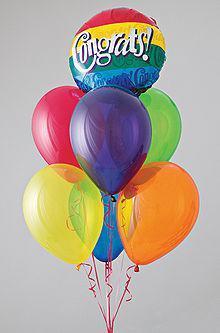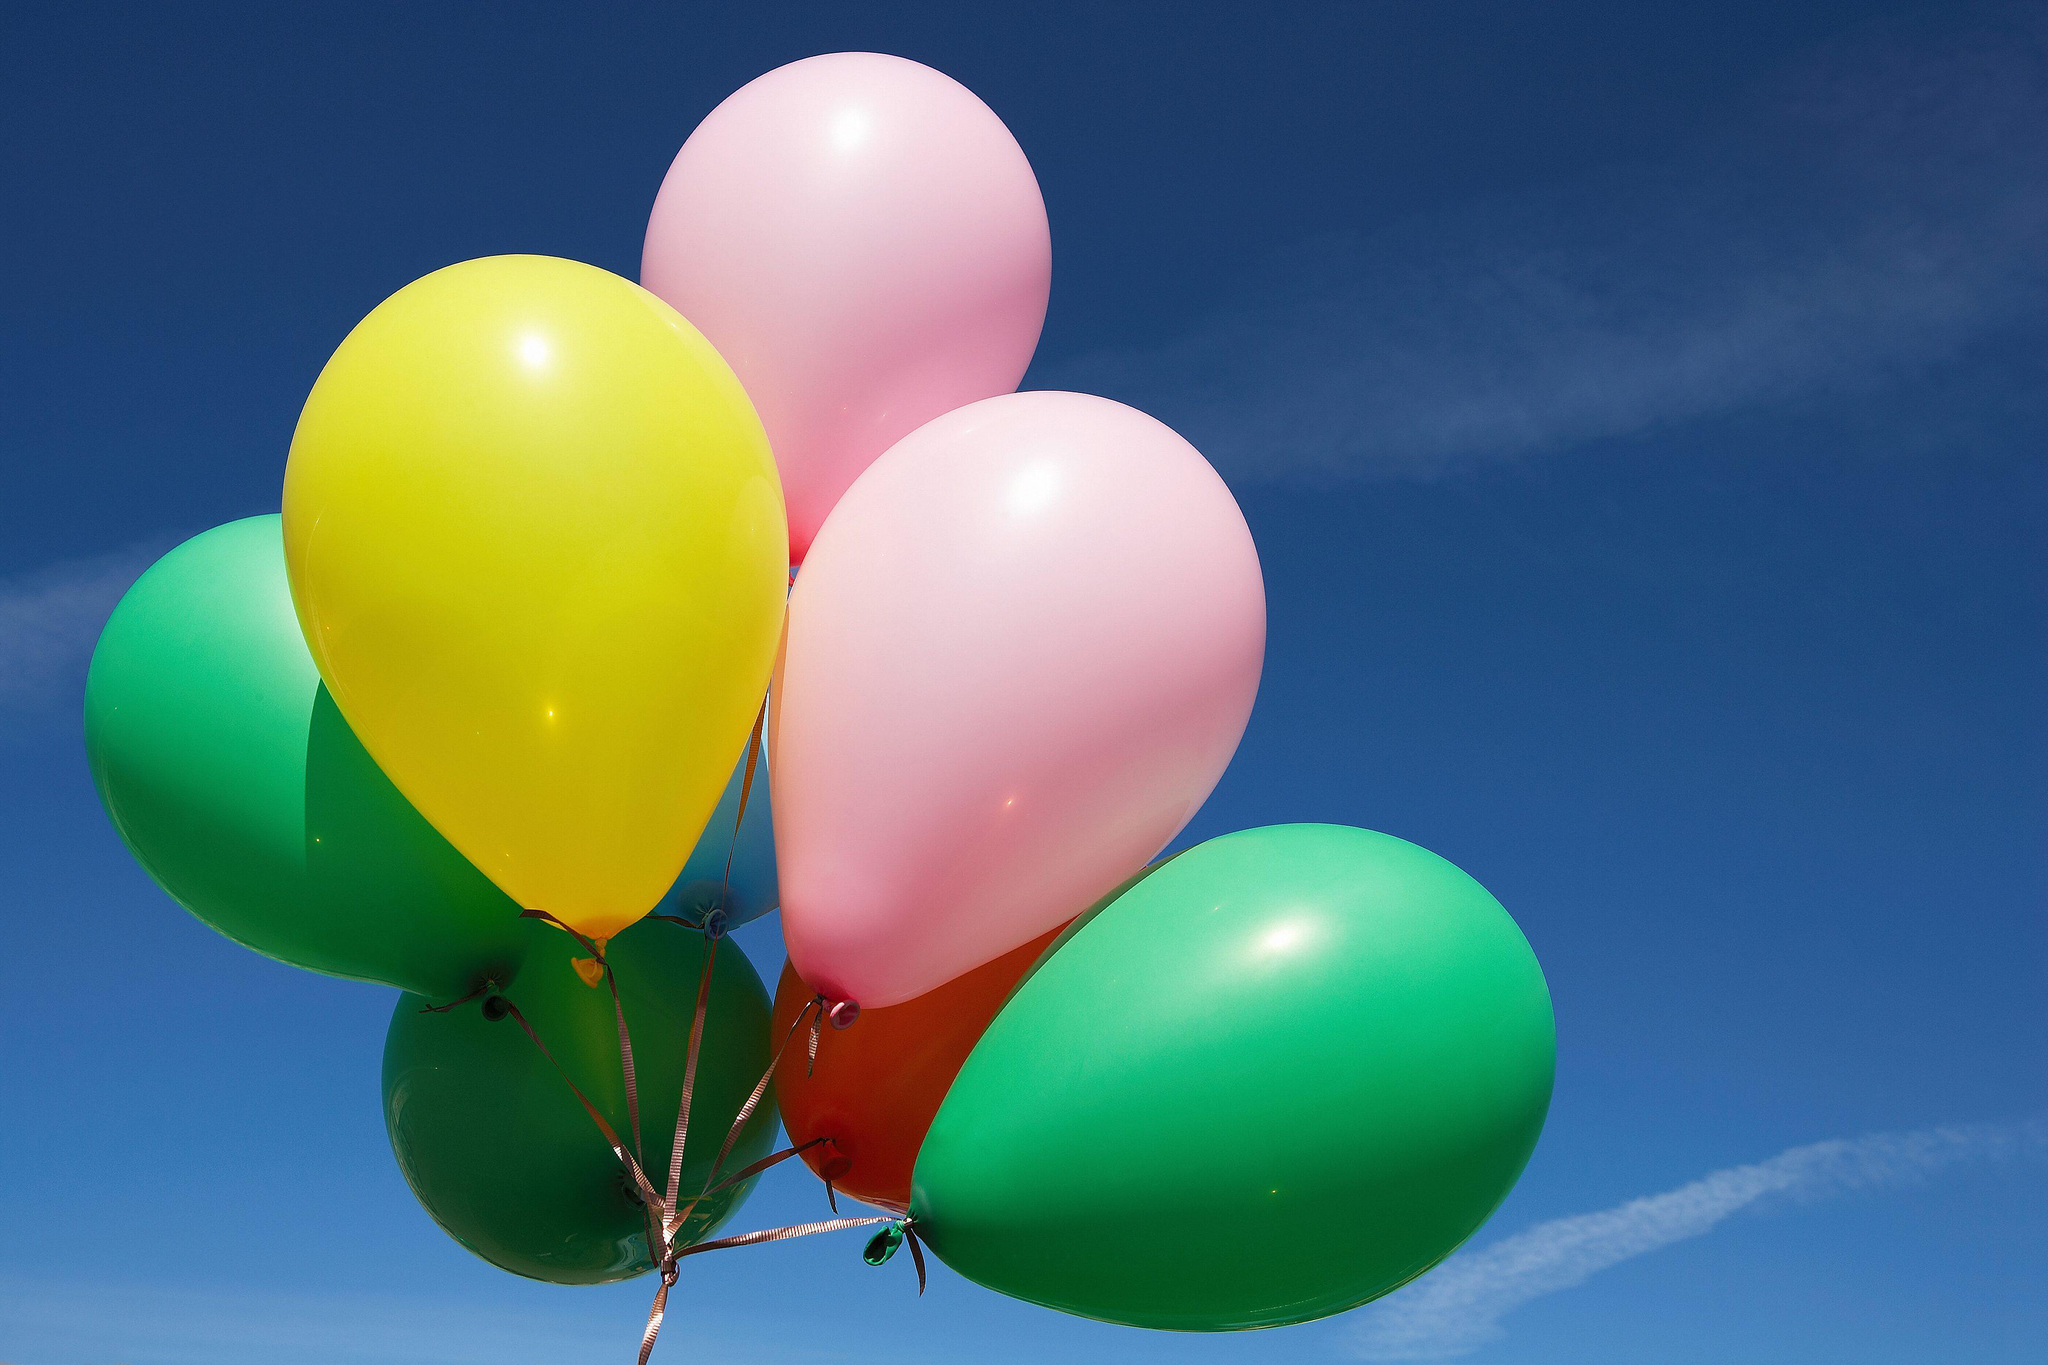The first image is the image on the left, the second image is the image on the right. Analyze the images presented: Is the assertion "The left image shows at least four balloons of the same color joined together, and one balloon of a different color." valid? Answer yes or no. No. The first image is the image on the left, the second image is the image on the right. Considering the images on both sides, is "In at least one image there is a total of five full balloons." valid? Answer yes or no. No. 